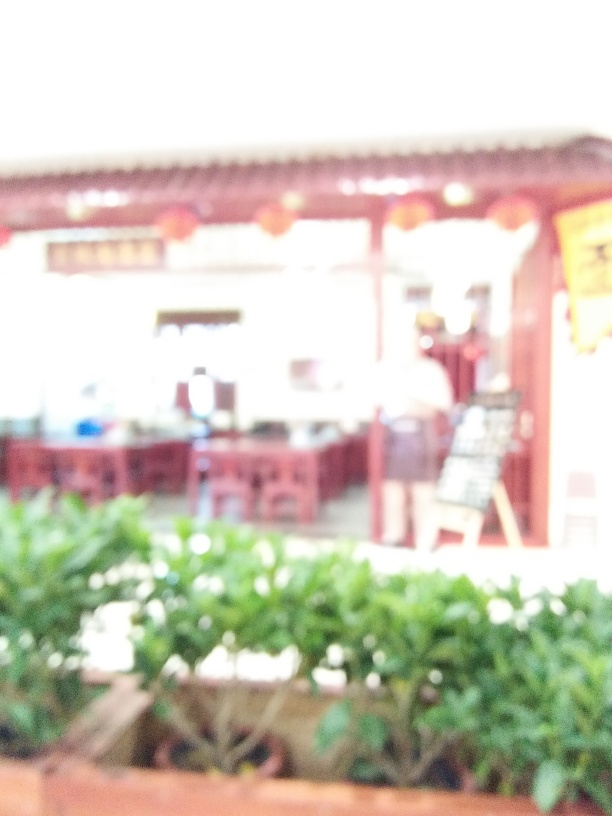Is the photo in focus?
A. No
B. Yes
Answer with the option's letter from the given choices directly.
 A. 